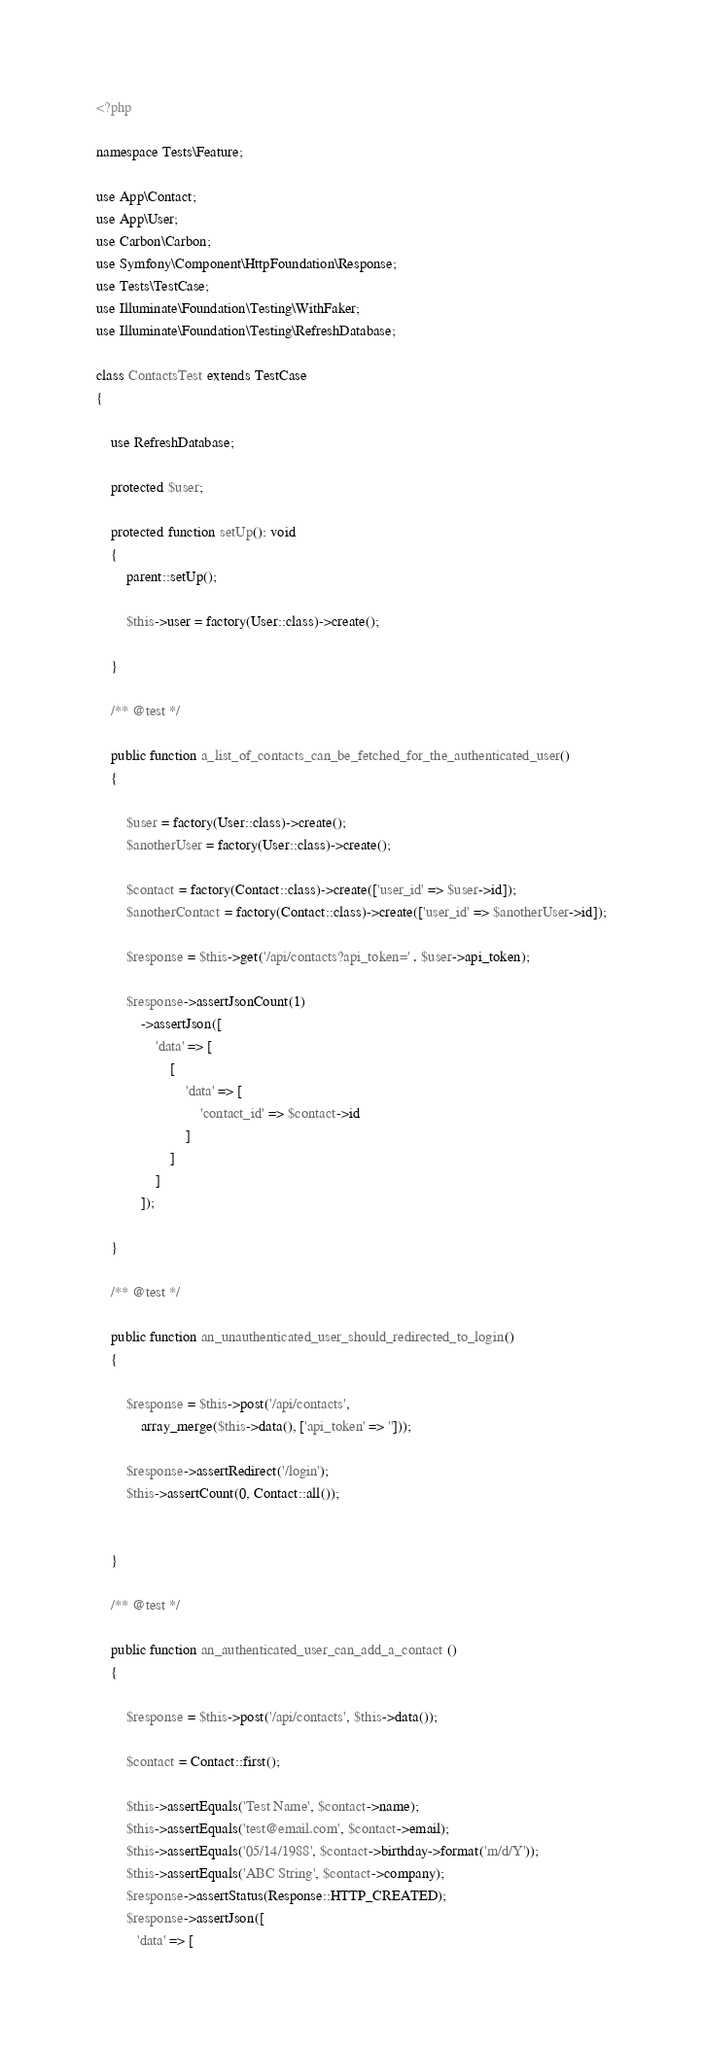<code> <loc_0><loc_0><loc_500><loc_500><_PHP_><?php

namespace Tests\Feature;

use App\Contact;
use App\User;
use Carbon\Carbon;
use Symfony\Component\HttpFoundation\Response;
use Tests\TestCase;
use Illuminate\Foundation\Testing\WithFaker;
use Illuminate\Foundation\Testing\RefreshDatabase;

class ContactsTest extends TestCase
{

    use RefreshDatabase;

    protected $user;

    protected function setUp(): void
    {
        parent::setUp();

        $this->user = factory(User::class)->create();

    }

    /** @test */

    public function a_list_of_contacts_can_be_fetched_for_the_authenticated_user()
    {

        $user = factory(User::class)->create();
        $anotherUser = factory(User::class)->create();

        $contact = factory(Contact::class)->create(['user_id' => $user->id]);
        $anotherContact = factory(Contact::class)->create(['user_id' => $anotherUser->id]);

        $response = $this->get('/api/contacts?api_token=' . $user->api_token);

        $response->assertJsonCount(1)
            ->assertJson([
                'data' => [
                    [
                        'data' => [
                            'contact_id' => $contact->id
                        ]
                    ]
                ]
            ]);

    }

    /** @test */

    public function an_unauthenticated_user_should_redirected_to_login()
    {

        $response = $this->post('/api/contacts',
            array_merge($this->data(), ['api_token' => '']));

        $response->assertRedirect('/login');
        $this->assertCount(0, Contact::all());


    }

    /** @test */

    public function an_authenticated_user_can_add_a_contact ()
    {

        $response = $this->post('/api/contacts', $this->data());

        $contact = Contact::first();

        $this->assertEquals('Test Name', $contact->name);
        $this->assertEquals('test@email.com', $contact->email);
        $this->assertEquals('05/14/1988', $contact->birthday->format('m/d/Y'));
        $this->assertEquals('ABC String', $contact->company);
        $response->assertStatus(Response::HTTP_CREATED);
        $response->assertJson([
           'data' => [</code> 